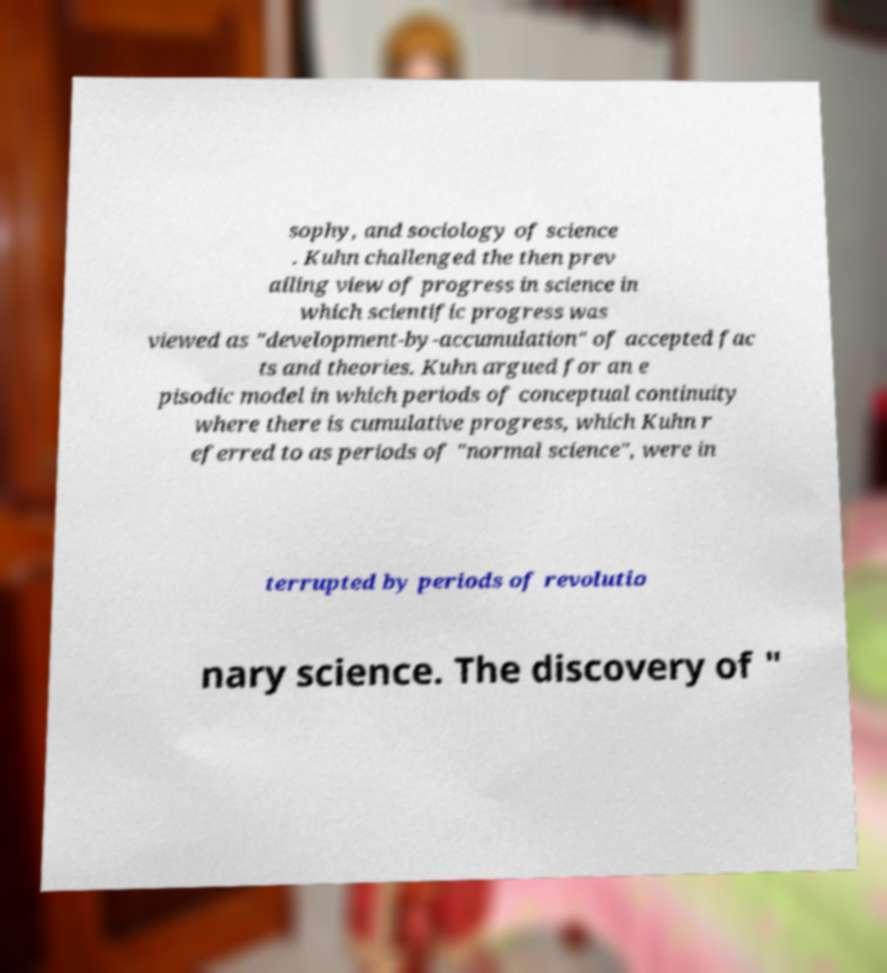Can you accurately transcribe the text from the provided image for me? sophy, and sociology of science . Kuhn challenged the then prev ailing view of progress in science in which scientific progress was viewed as "development-by-accumulation" of accepted fac ts and theories. Kuhn argued for an e pisodic model in which periods of conceptual continuity where there is cumulative progress, which Kuhn r eferred to as periods of "normal science", were in terrupted by periods of revolutio nary science. The discovery of " 